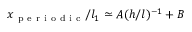Convert formula to latex. <formula><loc_0><loc_0><loc_500><loc_500>x _ { p e r i o d i c } / l _ { 1 } \simeq A ( h / l ) ^ { - 1 } + B</formula> 